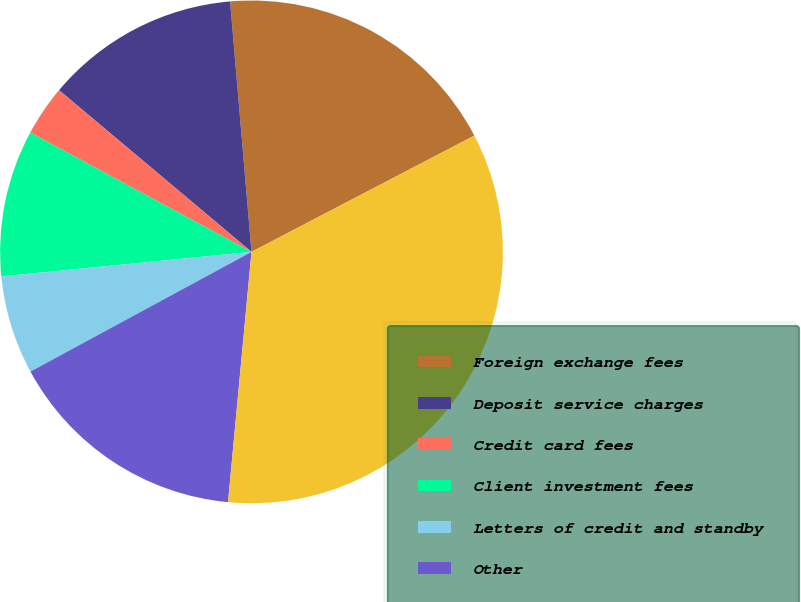Convert chart. <chart><loc_0><loc_0><loc_500><loc_500><pie_chart><fcel>Foreign exchange fees<fcel>Deposit service charges<fcel>Credit card fees<fcel>Client investment fees<fcel>Letters of credit and standby<fcel>Other<fcel>Total noninterest income<nl><fcel>18.7%<fcel>12.52%<fcel>3.25%<fcel>9.43%<fcel>6.34%<fcel>15.61%<fcel>34.14%<nl></chart> 